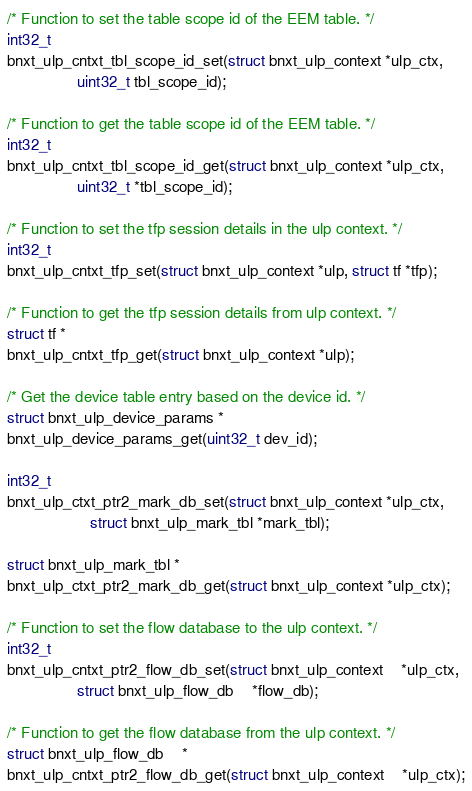Convert code to text. <code><loc_0><loc_0><loc_500><loc_500><_C_>
/* Function to set the table scope id of the EEM table. */
int32_t
bnxt_ulp_cntxt_tbl_scope_id_set(struct bnxt_ulp_context *ulp_ctx,
				uint32_t tbl_scope_id);

/* Function to get the table scope id of the EEM table. */
int32_t
bnxt_ulp_cntxt_tbl_scope_id_get(struct bnxt_ulp_context *ulp_ctx,
				uint32_t *tbl_scope_id);

/* Function to set the tfp session details in the ulp context. */
int32_t
bnxt_ulp_cntxt_tfp_set(struct bnxt_ulp_context *ulp, struct tf *tfp);

/* Function to get the tfp session details from ulp context. */
struct tf *
bnxt_ulp_cntxt_tfp_get(struct bnxt_ulp_context *ulp);

/* Get the device table entry based on the device id. */
struct bnxt_ulp_device_params *
bnxt_ulp_device_params_get(uint32_t dev_id);

int32_t
bnxt_ulp_ctxt_ptr2_mark_db_set(struct bnxt_ulp_context *ulp_ctx,
			       struct bnxt_ulp_mark_tbl *mark_tbl);

struct bnxt_ulp_mark_tbl *
bnxt_ulp_ctxt_ptr2_mark_db_get(struct bnxt_ulp_context *ulp_ctx);

/* Function to set the flow database to the ulp context. */
int32_t
bnxt_ulp_cntxt_ptr2_flow_db_set(struct bnxt_ulp_context	*ulp_ctx,
				struct bnxt_ulp_flow_db	*flow_db);

/* Function to get the flow database from the ulp context. */
struct bnxt_ulp_flow_db	*
bnxt_ulp_cntxt_ptr2_flow_db_get(struct bnxt_ulp_context	*ulp_ctx);
</code> 